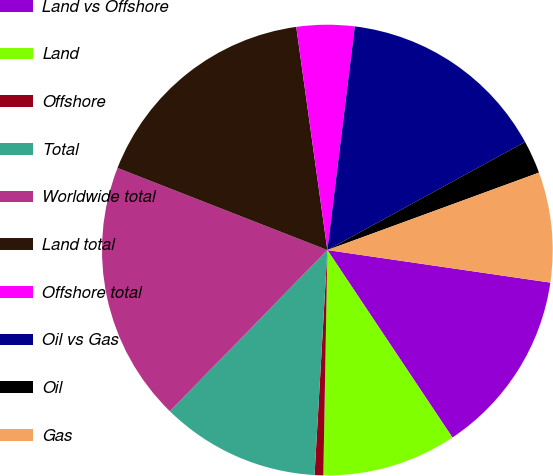Convert chart. <chart><loc_0><loc_0><loc_500><loc_500><pie_chart><fcel>Land vs Offshore<fcel>Land<fcel>Offshore<fcel>Total<fcel>Worldwide total<fcel>Land total<fcel>Offshore total<fcel>Oil vs Gas<fcel>Oil<fcel>Gas<nl><fcel>13.33%<fcel>9.65%<fcel>0.62%<fcel>11.41%<fcel>18.62%<fcel>16.86%<fcel>4.15%<fcel>15.09%<fcel>2.38%<fcel>7.89%<nl></chart> 